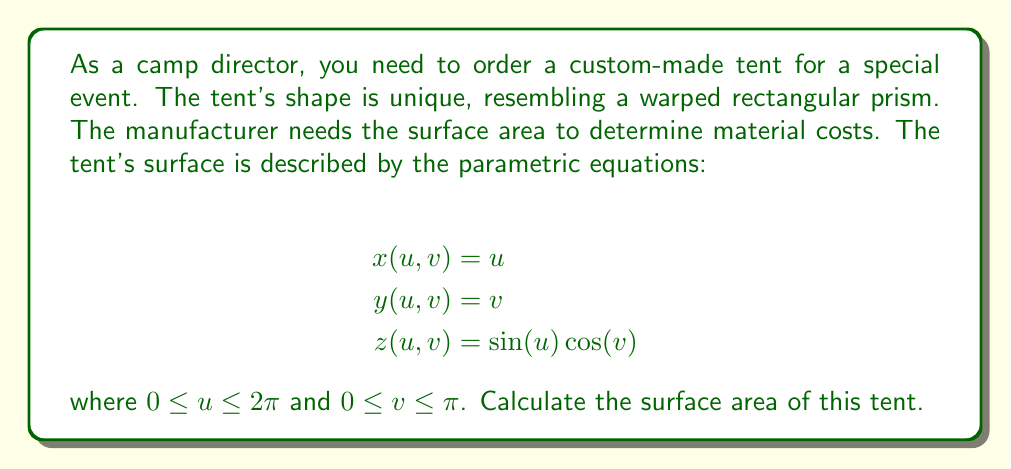Help me with this question. To find the surface area of a parametric surface, we use the formula:

$$\text{Surface Area} = \iint_D \sqrt{EG - F^2} \, du \, dv$$

where $E = x_u^2 + y_u^2 + z_u^2$, $G = x_v^2 + y_v^2 + z_v^2$, and $F = x_ux_v + y_uy_v + z_uz_v$.

Step 1: Calculate partial derivatives
$$x_u = 1, \quad y_u = 0, \quad z_u = \cos(u)\cos(v)$$
$$x_v = 0, \quad y_v = 1, \quad z_v = -\sin(u)\sin(v)$$

Step 2: Calculate E, G, and F
$$E = 1^2 + 0^2 + (\cos(u)\cos(v))^2 = 1 + \cos^2(u)\cos^2(v)$$
$$G = 0^2 + 1^2 + (-\sin(u)\sin(v))^2 = 1 + \sin^2(u)\sin^2(v)$$
$$F = (1)(0) + (0)(1) + (\cos(u)\cos(v))(-\sin(u)\sin(v)) = -\frac{1}{2}\sin(2u)\sin(2v)$$

Step 3: Calculate $EG - F^2$
$$EG - F^2 = (1 + \cos^2(u)\cos^2(v))(1 + \sin^2(u)\sin^2(v)) - (\frac{1}{2}\sin(2u)\sin(2v))^2$$

Step 4: Integrate to find the surface area
$$\text{Surface Area} = \int_0^{2\pi} \int_0^{\pi} \sqrt{EG - F^2} \, dv \, du$$

This integral is complex and doesn't have a simple closed-form solution. We need to use numerical integration techniques to evaluate it.

Step 5: Using numerical integration (e.g., Simpson's rule or a computer algebra system), we can approximate the surface area to be approximately 14.51 square units.
Answer: $14.51$ square units (approximate) 